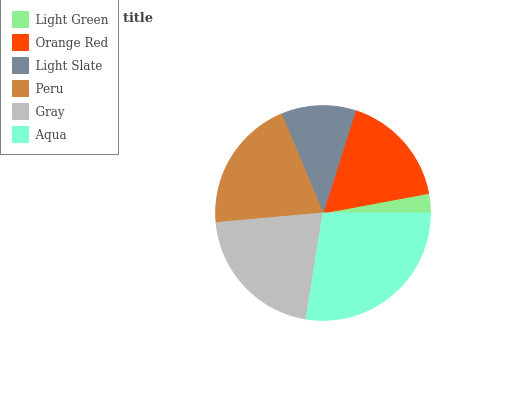Is Light Green the minimum?
Answer yes or no. Yes. Is Aqua the maximum?
Answer yes or no. Yes. Is Orange Red the minimum?
Answer yes or no. No. Is Orange Red the maximum?
Answer yes or no. No. Is Orange Red greater than Light Green?
Answer yes or no. Yes. Is Light Green less than Orange Red?
Answer yes or no. Yes. Is Light Green greater than Orange Red?
Answer yes or no. No. Is Orange Red less than Light Green?
Answer yes or no. No. Is Peru the high median?
Answer yes or no. Yes. Is Orange Red the low median?
Answer yes or no. Yes. Is Gray the high median?
Answer yes or no. No. Is Light Green the low median?
Answer yes or no. No. 